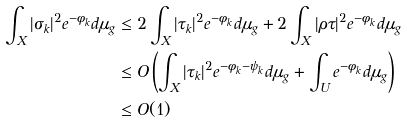Convert formula to latex. <formula><loc_0><loc_0><loc_500><loc_500>\int _ { X } | \sigma _ { k } | ^ { 2 } e ^ { - \phi _ { k } } d \mu _ { g } & \leq 2 \int _ { X } | \tau _ { k } | ^ { 2 } e ^ { - \phi _ { k } } d \mu _ { g } + 2 \int _ { X } | \rho \tau | ^ { 2 } e ^ { - \phi _ { k } } d \mu _ { g } \\ & \leq O \left ( \int _ { X } | \tau _ { k } | ^ { 2 } e ^ { - \phi _ { k } - \psi _ { k } } d \mu _ { g } + \int _ { U } e ^ { - \phi _ { k } } d \mu _ { g } \right ) \\ & \leq O ( 1 ) \\</formula> 